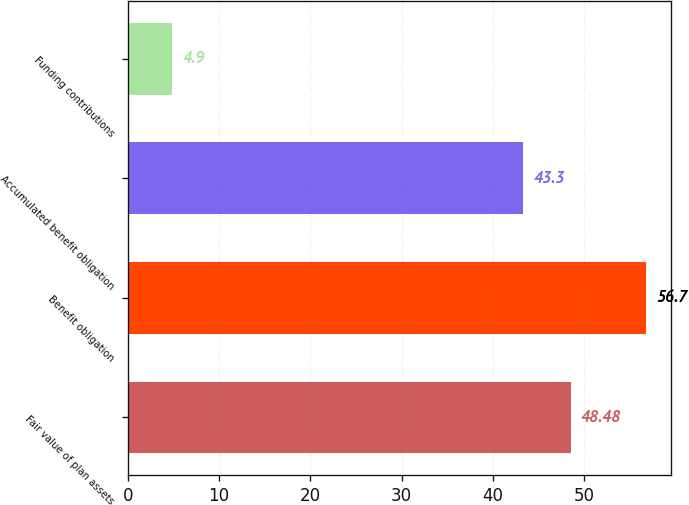Convert chart. <chart><loc_0><loc_0><loc_500><loc_500><bar_chart><fcel>Fair value of plan assets<fcel>Benefit obligation<fcel>Accumulated benefit obligation<fcel>Funding contributions<nl><fcel>48.48<fcel>56.7<fcel>43.3<fcel>4.9<nl></chart> 